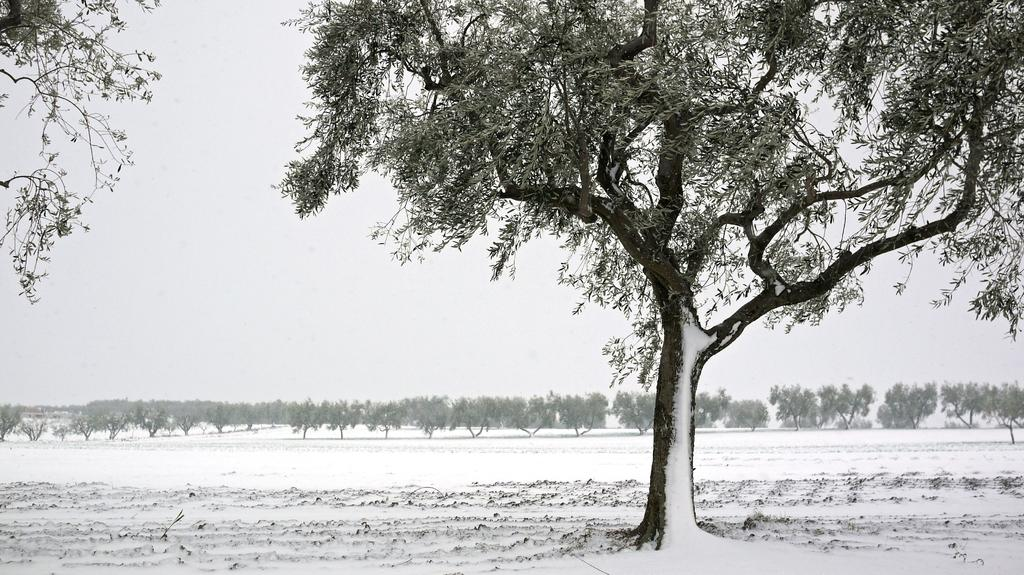What type of vegetation can be seen in the image? There are trees in the image. What is visible in the background of the image? The sky is visible in the background of the image. What type of street can be seen in the image? There is no street present in the image; it only features trees and the sky. Is the image set during the night or day? The image does not provide any information about the time of day, so it cannot be determined whether it is set during the night or day. 